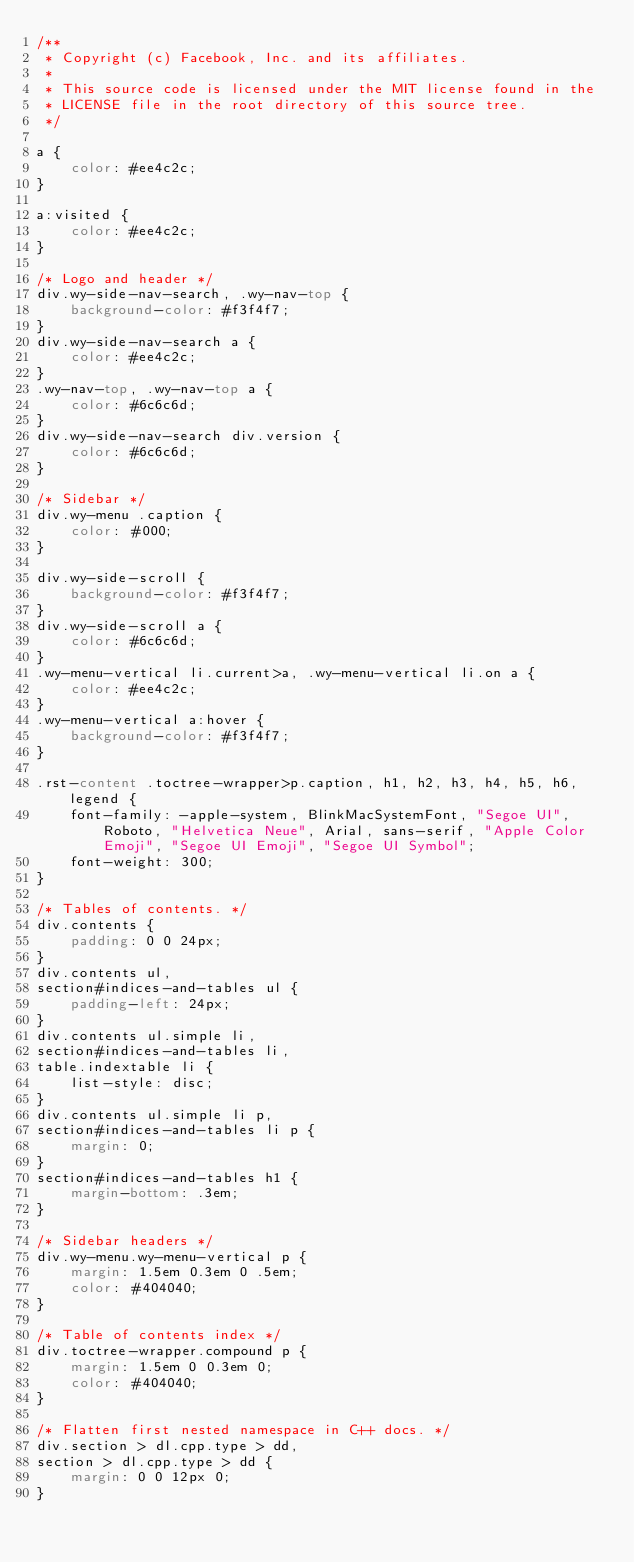<code> <loc_0><loc_0><loc_500><loc_500><_CSS_>/**
 * Copyright (c) Facebook, Inc. and its affiliates.
 *
 * This source code is licensed under the MIT license found in the
 * LICENSE file in the root directory of this source tree.
 */

a {
	color: #ee4c2c;
}

a:visited {
	color: #ee4c2c;
}

/* Logo and header */
div.wy-side-nav-search, .wy-nav-top {
	background-color: #f3f4f7;
}
div.wy-side-nav-search a {
	color: #ee4c2c;
}
.wy-nav-top, .wy-nav-top a {
	color: #6c6c6d;
}
div.wy-side-nav-search div.version {
	color: #6c6c6d;
}

/* Sidebar */
div.wy-menu .caption {
	color: #000;
}

div.wy-side-scroll {
	background-color: #f3f4f7;
}
div.wy-side-scroll a {
	color: #6c6c6d;
}
.wy-menu-vertical li.current>a, .wy-menu-vertical li.on a {
	color: #ee4c2c;
}
.wy-menu-vertical a:hover {
	background-color: #f3f4f7;
}

.rst-content .toctree-wrapper>p.caption, h1, h2, h3, h4, h5, h6, legend {
	font-family: -apple-system, BlinkMacSystemFont, "Segoe UI", Roboto, "Helvetica Neue", Arial, sans-serif, "Apple Color Emoji", "Segoe UI Emoji", "Segoe UI Symbol";
	font-weight: 300;
}

/* Tables of contents. */
div.contents {
	padding: 0 0 24px;
}
div.contents ul,
section#indices-and-tables ul {
	padding-left: 24px;
}
div.contents ul.simple li,
section#indices-and-tables li,
table.indextable li {
	list-style: disc;
}
div.contents ul.simple li p,
section#indices-and-tables li p {
	margin: 0;
}
section#indices-and-tables h1 {
	margin-bottom: .3em;
}

/* Sidebar headers */
div.wy-menu.wy-menu-vertical p {
	margin: 1.5em 0.3em 0 .5em;
	color: #404040;
}

/* Table of contents index */
div.toctree-wrapper.compound p {
	margin: 1.5em 0 0.3em 0;
	color: #404040;
}

/* Flatten first nested namespace in C++ docs. */
div.section > dl.cpp.type > dd,
section > dl.cpp.type > dd {
	margin: 0 0 12px 0;
}
</code> 